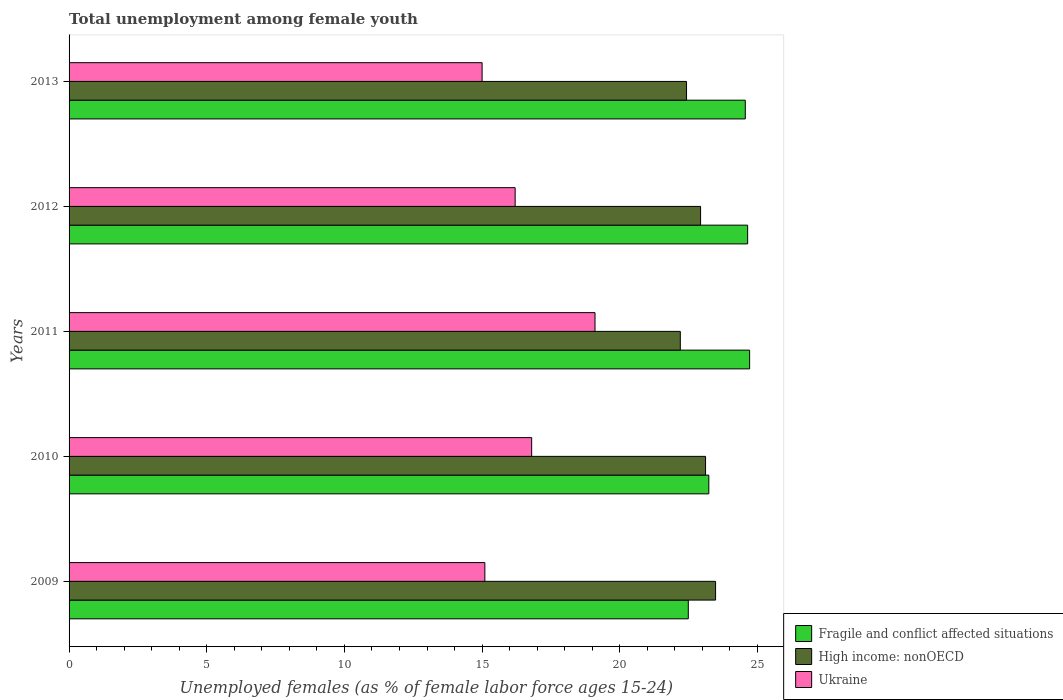How many different coloured bars are there?
Your answer should be compact. 3. How many groups of bars are there?
Offer a terse response. 5. Are the number of bars on each tick of the Y-axis equal?
Your answer should be compact. Yes. How many bars are there on the 2nd tick from the top?
Make the answer very short. 3. Across all years, what is the maximum percentage of unemployed females in in Fragile and conflict affected situations?
Keep it short and to the point. 24.71. Across all years, what is the minimum percentage of unemployed females in in Fragile and conflict affected situations?
Give a very brief answer. 22.49. What is the total percentage of unemployed females in in Fragile and conflict affected situations in the graph?
Offer a terse response. 119.64. What is the difference between the percentage of unemployed females in in Fragile and conflict affected situations in 2012 and that in 2013?
Your answer should be compact. 0.08. What is the difference between the percentage of unemployed females in in Fragile and conflict affected situations in 2010 and the percentage of unemployed females in in High income: nonOECD in 2013?
Provide a succinct answer. 0.81. What is the average percentage of unemployed females in in Ukraine per year?
Provide a short and direct response. 16.44. In the year 2013, what is the difference between the percentage of unemployed females in in Fragile and conflict affected situations and percentage of unemployed females in in Ukraine?
Give a very brief answer. 9.56. In how many years, is the percentage of unemployed females in in Ukraine greater than 15 %?
Offer a terse response. 4. What is the ratio of the percentage of unemployed females in in High income: nonOECD in 2009 to that in 2013?
Your answer should be compact. 1.05. What is the difference between the highest and the second highest percentage of unemployed females in in High income: nonOECD?
Offer a terse response. 0.36. What is the difference between the highest and the lowest percentage of unemployed females in in High income: nonOECD?
Your answer should be compact. 1.28. In how many years, is the percentage of unemployed females in in Ukraine greater than the average percentage of unemployed females in in Ukraine taken over all years?
Make the answer very short. 2. What does the 2nd bar from the top in 2010 represents?
Give a very brief answer. High income: nonOECD. What does the 1st bar from the bottom in 2011 represents?
Provide a short and direct response. Fragile and conflict affected situations. Are all the bars in the graph horizontal?
Give a very brief answer. Yes. What is the difference between two consecutive major ticks on the X-axis?
Provide a succinct answer. 5. Does the graph contain any zero values?
Offer a terse response. No. Where does the legend appear in the graph?
Make the answer very short. Bottom right. How are the legend labels stacked?
Ensure brevity in your answer.  Vertical. What is the title of the graph?
Ensure brevity in your answer.  Total unemployment among female youth. Does "Cameroon" appear as one of the legend labels in the graph?
Make the answer very short. No. What is the label or title of the X-axis?
Give a very brief answer. Unemployed females (as % of female labor force ages 15-24). What is the label or title of the Y-axis?
Give a very brief answer. Years. What is the Unemployed females (as % of female labor force ages 15-24) in Fragile and conflict affected situations in 2009?
Offer a terse response. 22.49. What is the Unemployed females (as % of female labor force ages 15-24) in High income: nonOECD in 2009?
Give a very brief answer. 23.48. What is the Unemployed females (as % of female labor force ages 15-24) in Ukraine in 2009?
Provide a succinct answer. 15.1. What is the Unemployed females (as % of female labor force ages 15-24) of Fragile and conflict affected situations in 2010?
Your answer should be very brief. 23.23. What is the Unemployed females (as % of female labor force ages 15-24) of High income: nonOECD in 2010?
Ensure brevity in your answer.  23.11. What is the Unemployed females (as % of female labor force ages 15-24) in Ukraine in 2010?
Your answer should be compact. 16.8. What is the Unemployed females (as % of female labor force ages 15-24) of Fragile and conflict affected situations in 2011?
Offer a very short reply. 24.71. What is the Unemployed females (as % of female labor force ages 15-24) in High income: nonOECD in 2011?
Your answer should be very brief. 22.2. What is the Unemployed females (as % of female labor force ages 15-24) of Ukraine in 2011?
Provide a short and direct response. 19.1. What is the Unemployed females (as % of female labor force ages 15-24) of Fragile and conflict affected situations in 2012?
Your answer should be compact. 24.64. What is the Unemployed females (as % of female labor force ages 15-24) in High income: nonOECD in 2012?
Make the answer very short. 22.93. What is the Unemployed females (as % of female labor force ages 15-24) of Ukraine in 2012?
Your answer should be very brief. 16.2. What is the Unemployed females (as % of female labor force ages 15-24) in Fragile and conflict affected situations in 2013?
Ensure brevity in your answer.  24.56. What is the Unemployed females (as % of female labor force ages 15-24) in High income: nonOECD in 2013?
Your response must be concise. 22.42. What is the Unemployed females (as % of female labor force ages 15-24) in Ukraine in 2013?
Offer a terse response. 15. Across all years, what is the maximum Unemployed females (as % of female labor force ages 15-24) in Fragile and conflict affected situations?
Keep it short and to the point. 24.71. Across all years, what is the maximum Unemployed females (as % of female labor force ages 15-24) in High income: nonOECD?
Provide a succinct answer. 23.48. Across all years, what is the maximum Unemployed females (as % of female labor force ages 15-24) in Ukraine?
Give a very brief answer. 19.1. Across all years, what is the minimum Unemployed females (as % of female labor force ages 15-24) of Fragile and conflict affected situations?
Your response must be concise. 22.49. Across all years, what is the minimum Unemployed females (as % of female labor force ages 15-24) of High income: nonOECD?
Provide a short and direct response. 22.2. Across all years, what is the minimum Unemployed females (as % of female labor force ages 15-24) in Ukraine?
Your answer should be very brief. 15. What is the total Unemployed females (as % of female labor force ages 15-24) of Fragile and conflict affected situations in the graph?
Your answer should be very brief. 119.64. What is the total Unemployed females (as % of female labor force ages 15-24) of High income: nonOECD in the graph?
Make the answer very short. 114.15. What is the total Unemployed females (as % of female labor force ages 15-24) in Ukraine in the graph?
Your answer should be very brief. 82.2. What is the difference between the Unemployed females (as % of female labor force ages 15-24) of Fragile and conflict affected situations in 2009 and that in 2010?
Your response must be concise. -0.75. What is the difference between the Unemployed females (as % of female labor force ages 15-24) of High income: nonOECD in 2009 and that in 2010?
Make the answer very short. 0.36. What is the difference between the Unemployed females (as % of female labor force ages 15-24) in Ukraine in 2009 and that in 2010?
Keep it short and to the point. -1.7. What is the difference between the Unemployed females (as % of female labor force ages 15-24) of Fragile and conflict affected situations in 2009 and that in 2011?
Keep it short and to the point. -2.23. What is the difference between the Unemployed females (as % of female labor force ages 15-24) in High income: nonOECD in 2009 and that in 2011?
Keep it short and to the point. 1.28. What is the difference between the Unemployed females (as % of female labor force ages 15-24) in Ukraine in 2009 and that in 2011?
Your answer should be very brief. -4. What is the difference between the Unemployed females (as % of female labor force ages 15-24) of Fragile and conflict affected situations in 2009 and that in 2012?
Your response must be concise. -2.16. What is the difference between the Unemployed females (as % of female labor force ages 15-24) of High income: nonOECD in 2009 and that in 2012?
Your answer should be very brief. 0.54. What is the difference between the Unemployed females (as % of female labor force ages 15-24) in Ukraine in 2009 and that in 2012?
Your answer should be compact. -1.1. What is the difference between the Unemployed females (as % of female labor force ages 15-24) in Fragile and conflict affected situations in 2009 and that in 2013?
Keep it short and to the point. -2.07. What is the difference between the Unemployed females (as % of female labor force ages 15-24) in High income: nonOECD in 2009 and that in 2013?
Your answer should be very brief. 1.06. What is the difference between the Unemployed females (as % of female labor force ages 15-24) in Fragile and conflict affected situations in 2010 and that in 2011?
Give a very brief answer. -1.48. What is the difference between the Unemployed females (as % of female labor force ages 15-24) in Fragile and conflict affected situations in 2010 and that in 2012?
Your answer should be very brief. -1.41. What is the difference between the Unemployed females (as % of female labor force ages 15-24) of High income: nonOECD in 2010 and that in 2012?
Ensure brevity in your answer.  0.18. What is the difference between the Unemployed females (as % of female labor force ages 15-24) in Ukraine in 2010 and that in 2012?
Provide a short and direct response. 0.6. What is the difference between the Unemployed females (as % of female labor force ages 15-24) of Fragile and conflict affected situations in 2010 and that in 2013?
Offer a terse response. -1.32. What is the difference between the Unemployed females (as % of female labor force ages 15-24) of High income: nonOECD in 2010 and that in 2013?
Your answer should be compact. 0.69. What is the difference between the Unemployed females (as % of female labor force ages 15-24) in Ukraine in 2010 and that in 2013?
Your response must be concise. 1.8. What is the difference between the Unemployed females (as % of female labor force ages 15-24) in Fragile and conflict affected situations in 2011 and that in 2012?
Offer a terse response. 0.07. What is the difference between the Unemployed females (as % of female labor force ages 15-24) of High income: nonOECD in 2011 and that in 2012?
Provide a succinct answer. -0.74. What is the difference between the Unemployed females (as % of female labor force ages 15-24) in Ukraine in 2011 and that in 2012?
Offer a very short reply. 2.9. What is the difference between the Unemployed females (as % of female labor force ages 15-24) of Fragile and conflict affected situations in 2011 and that in 2013?
Offer a terse response. 0.16. What is the difference between the Unemployed females (as % of female labor force ages 15-24) in High income: nonOECD in 2011 and that in 2013?
Make the answer very short. -0.23. What is the difference between the Unemployed females (as % of female labor force ages 15-24) of Fragile and conflict affected situations in 2012 and that in 2013?
Your answer should be compact. 0.09. What is the difference between the Unemployed females (as % of female labor force ages 15-24) of High income: nonOECD in 2012 and that in 2013?
Ensure brevity in your answer.  0.51. What is the difference between the Unemployed females (as % of female labor force ages 15-24) of Ukraine in 2012 and that in 2013?
Keep it short and to the point. 1.2. What is the difference between the Unemployed females (as % of female labor force ages 15-24) in Fragile and conflict affected situations in 2009 and the Unemployed females (as % of female labor force ages 15-24) in High income: nonOECD in 2010?
Ensure brevity in your answer.  -0.63. What is the difference between the Unemployed females (as % of female labor force ages 15-24) in Fragile and conflict affected situations in 2009 and the Unemployed females (as % of female labor force ages 15-24) in Ukraine in 2010?
Provide a succinct answer. 5.69. What is the difference between the Unemployed females (as % of female labor force ages 15-24) in High income: nonOECD in 2009 and the Unemployed females (as % of female labor force ages 15-24) in Ukraine in 2010?
Offer a very short reply. 6.68. What is the difference between the Unemployed females (as % of female labor force ages 15-24) in Fragile and conflict affected situations in 2009 and the Unemployed females (as % of female labor force ages 15-24) in High income: nonOECD in 2011?
Ensure brevity in your answer.  0.29. What is the difference between the Unemployed females (as % of female labor force ages 15-24) in Fragile and conflict affected situations in 2009 and the Unemployed females (as % of female labor force ages 15-24) in Ukraine in 2011?
Your response must be concise. 3.39. What is the difference between the Unemployed females (as % of female labor force ages 15-24) of High income: nonOECD in 2009 and the Unemployed females (as % of female labor force ages 15-24) of Ukraine in 2011?
Offer a very short reply. 4.38. What is the difference between the Unemployed females (as % of female labor force ages 15-24) of Fragile and conflict affected situations in 2009 and the Unemployed females (as % of female labor force ages 15-24) of High income: nonOECD in 2012?
Give a very brief answer. -0.45. What is the difference between the Unemployed females (as % of female labor force ages 15-24) in Fragile and conflict affected situations in 2009 and the Unemployed females (as % of female labor force ages 15-24) in Ukraine in 2012?
Ensure brevity in your answer.  6.29. What is the difference between the Unemployed females (as % of female labor force ages 15-24) of High income: nonOECD in 2009 and the Unemployed females (as % of female labor force ages 15-24) of Ukraine in 2012?
Provide a succinct answer. 7.28. What is the difference between the Unemployed females (as % of female labor force ages 15-24) of Fragile and conflict affected situations in 2009 and the Unemployed females (as % of female labor force ages 15-24) of High income: nonOECD in 2013?
Your answer should be compact. 0.06. What is the difference between the Unemployed females (as % of female labor force ages 15-24) of Fragile and conflict affected situations in 2009 and the Unemployed females (as % of female labor force ages 15-24) of Ukraine in 2013?
Your answer should be compact. 7.49. What is the difference between the Unemployed females (as % of female labor force ages 15-24) in High income: nonOECD in 2009 and the Unemployed females (as % of female labor force ages 15-24) in Ukraine in 2013?
Keep it short and to the point. 8.48. What is the difference between the Unemployed females (as % of female labor force ages 15-24) of Fragile and conflict affected situations in 2010 and the Unemployed females (as % of female labor force ages 15-24) of High income: nonOECD in 2011?
Your answer should be compact. 1.04. What is the difference between the Unemployed females (as % of female labor force ages 15-24) of Fragile and conflict affected situations in 2010 and the Unemployed females (as % of female labor force ages 15-24) of Ukraine in 2011?
Keep it short and to the point. 4.13. What is the difference between the Unemployed females (as % of female labor force ages 15-24) of High income: nonOECD in 2010 and the Unemployed females (as % of female labor force ages 15-24) of Ukraine in 2011?
Keep it short and to the point. 4.01. What is the difference between the Unemployed females (as % of female labor force ages 15-24) of Fragile and conflict affected situations in 2010 and the Unemployed females (as % of female labor force ages 15-24) of High income: nonOECD in 2012?
Your answer should be very brief. 0.3. What is the difference between the Unemployed females (as % of female labor force ages 15-24) in Fragile and conflict affected situations in 2010 and the Unemployed females (as % of female labor force ages 15-24) in Ukraine in 2012?
Your response must be concise. 7.03. What is the difference between the Unemployed females (as % of female labor force ages 15-24) of High income: nonOECD in 2010 and the Unemployed females (as % of female labor force ages 15-24) of Ukraine in 2012?
Keep it short and to the point. 6.91. What is the difference between the Unemployed females (as % of female labor force ages 15-24) of Fragile and conflict affected situations in 2010 and the Unemployed females (as % of female labor force ages 15-24) of High income: nonOECD in 2013?
Provide a succinct answer. 0.81. What is the difference between the Unemployed females (as % of female labor force ages 15-24) in Fragile and conflict affected situations in 2010 and the Unemployed females (as % of female labor force ages 15-24) in Ukraine in 2013?
Offer a very short reply. 8.23. What is the difference between the Unemployed females (as % of female labor force ages 15-24) of High income: nonOECD in 2010 and the Unemployed females (as % of female labor force ages 15-24) of Ukraine in 2013?
Make the answer very short. 8.11. What is the difference between the Unemployed females (as % of female labor force ages 15-24) of Fragile and conflict affected situations in 2011 and the Unemployed females (as % of female labor force ages 15-24) of High income: nonOECD in 2012?
Provide a succinct answer. 1.78. What is the difference between the Unemployed females (as % of female labor force ages 15-24) of Fragile and conflict affected situations in 2011 and the Unemployed females (as % of female labor force ages 15-24) of Ukraine in 2012?
Your response must be concise. 8.51. What is the difference between the Unemployed females (as % of female labor force ages 15-24) of High income: nonOECD in 2011 and the Unemployed females (as % of female labor force ages 15-24) of Ukraine in 2012?
Your response must be concise. 6. What is the difference between the Unemployed females (as % of female labor force ages 15-24) of Fragile and conflict affected situations in 2011 and the Unemployed females (as % of female labor force ages 15-24) of High income: nonOECD in 2013?
Give a very brief answer. 2.29. What is the difference between the Unemployed females (as % of female labor force ages 15-24) of Fragile and conflict affected situations in 2011 and the Unemployed females (as % of female labor force ages 15-24) of Ukraine in 2013?
Provide a short and direct response. 9.71. What is the difference between the Unemployed females (as % of female labor force ages 15-24) in High income: nonOECD in 2011 and the Unemployed females (as % of female labor force ages 15-24) in Ukraine in 2013?
Make the answer very short. 7.2. What is the difference between the Unemployed females (as % of female labor force ages 15-24) in Fragile and conflict affected situations in 2012 and the Unemployed females (as % of female labor force ages 15-24) in High income: nonOECD in 2013?
Offer a very short reply. 2.22. What is the difference between the Unemployed females (as % of female labor force ages 15-24) of Fragile and conflict affected situations in 2012 and the Unemployed females (as % of female labor force ages 15-24) of Ukraine in 2013?
Offer a very short reply. 9.64. What is the difference between the Unemployed females (as % of female labor force ages 15-24) in High income: nonOECD in 2012 and the Unemployed females (as % of female labor force ages 15-24) in Ukraine in 2013?
Provide a succinct answer. 7.93. What is the average Unemployed females (as % of female labor force ages 15-24) of Fragile and conflict affected situations per year?
Give a very brief answer. 23.93. What is the average Unemployed females (as % of female labor force ages 15-24) in High income: nonOECD per year?
Make the answer very short. 22.83. What is the average Unemployed females (as % of female labor force ages 15-24) in Ukraine per year?
Provide a short and direct response. 16.44. In the year 2009, what is the difference between the Unemployed females (as % of female labor force ages 15-24) of Fragile and conflict affected situations and Unemployed females (as % of female labor force ages 15-24) of High income: nonOECD?
Your response must be concise. -0.99. In the year 2009, what is the difference between the Unemployed females (as % of female labor force ages 15-24) of Fragile and conflict affected situations and Unemployed females (as % of female labor force ages 15-24) of Ukraine?
Give a very brief answer. 7.39. In the year 2009, what is the difference between the Unemployed females (as % of female labor force ages 15-24) of High income: nonOECD and Unemployed females (as % of female labor force ages 15-24) of Ukraine?
Provide a short and direct response. 8.38. In the year 2010, what is the difference between the Unemployed females (as % of female labor force ages 15-24) of Fragile and conflict affected situations and Unemployed females (as % of female labor force ages 15-24) of High income: nonOECD?
Your answer should be compact. 0.12. In the year 2010, what is the difference between the Unemployed females (as % of female labor force ages 15-24) in Fragile and conflict affected situations and Unemployed females (as % of female labor force ages 15-24) in Ukraine?
Your answer should be compact. 6.43. In the year 2010, what is the difference between the Unemployed females (as % of female labor force ages 15-24) in High income: nonOECD and Unemployed females (as % of female labor force ages 15-24) in Ukraine?
Provide a succinct answer. 6.31. In the year 2011, what is the difference between the Unemployed females (as % of female labor force ages 15-24) of Fragile and conflict affected situations and Unemployed females (as % of female labor force ages 15-24) of High income: nonOECD?
Your answer should be very brief. 2.52. In the year 2011, what is the difference between the Unemployed females (as % of female labor force ages 15-24) of Fragile and conflict affected situations and Unemployed females (as % of female labor force ages 15-24) of Ukraine?
Make the answer very short. 5.61. In the year 2011, what is the difference between the Unemployed females (as % of female labor force ages 15-24) of High income: nonOECD and Unemployed females (as % of female labor force ages 15-24) of Ukraine?
Provide a succinct answer. 3.1. In the year 2012, what is the difference between the Unemployed females (as % of female labor force ages 15-24) in Fragile and conflict affected situations and Unemployed females (as % of female labor force ages 15-24) in High income: nonOECD?
Ensure brevity in your answer.  1.71. In the year 2012, what is the difference between the Unemployed females (as % of female labor force ages 15-24) of Fragile and conflict affected situations and Unemployed females (as % of female labor force ages 15-24) of Ukraine?
Your answer should be very brief. 8.44. In the year 2012, what is the difference between the Unemployed females (as % of female labor force ages 15-24) of High income: nonOECD and Unemployed females (as % of female labor force ages 15-24) of Ukraine?
Offer a terse response. 6.73. In the year 2013, what is the difference between the Unemployed females (as % of female labor force ages 15-24) of Fragile and conflict affected situations and Unemployed females (as % of female labor force ages 15-24) of High income: nonOECD?
Your answer should be compact. 2.13. In the year 2013, what is the difference between the Unemployed females (as % of female labor force ages 15-24) of Fragile and conflict affected situations and Unemployed females (as % of female labor force ages 15-24) of Ukraine?
Ensure brevity in your answer.  9.56. In the year 2013, what is the difference between the Unemployed females (as % of female labor force ages 15-24) in High income: nonOECD and Unemployed females (as % of female labor force ages 15-24) in Ukraine?
Keep it short and to the point. 7.42. What is the ratio of the Unemployed females (as % of female labor force ages 15-24) of Fragile and conflict affected situations in 2009 to that in 2010?
Your response must be concise. 0.97. What is the ratio of the Unemployed females (as % of female labor force ages 15-24) in High income: nonOECD in 2009 to that in 2010?
Keep it short and to the point. 1.02. What is the ratio of the Unemployed females (as % of female labor force ages 15-24) of Ukraine in 2009 to that in 2010?
Provide a short and direct response. 0.9. What is the ratio of the Unemployed females (as % of female labor force ages 15-24) of Fragile and conflict affected situations in 2009 to that in 2011?
Offer a terse response. 0.91. What is the ratio of the Unemployed females (as % of female labor force ages 15-24) of High income: nonOECD in 2009 to that in 2011?
Ensure brevity in your answer.  1.06. What is the ratio of the Unemployed females (as % of female labor force ages 15-24) in Ukraine in 2009 to that in 2011?
Offer a very short reply. 0.79. What is the ratio of the Unemployed females (as % of female labor force ages 15-24) in Fragile and conflict affected situations in 2009 to that in 2012?
Give a very brief answer. 0.91. What is the ratio of the Unemployed females (as % of female labor force ages 15-24) of High income: nonOECD in 2009 to that in 2012?
Your response must be concise. 1.02. What is the ratio of the Unemployed females (as % of female labor force ages 15-24) in Ukraine in 2009 to that in 2012?
Give a very brief answer. 0.93. What is the ratio of the Unemployed females (as % of female labor force ages 15-24) of Fragile and conflict affected situations in 2009 to that in 2013?
Give a very brief answer. 0.92. What is the ratio of the Unemployed females (as % of female labor force ages 15-24) in High income: nonOECD in 2009 to that in 2013?
Your answer should be compact. 1.05. What is the ratio of the Unemployed females (as % of female labor force ages 15-24) of High income: nonOECD in 2010 to that in 2011?
Ensure brevity in your answer.  1.04. What is the ratio of the Unemployed females (as % of female labor force ages 15-24) in Ukraine in 2010 to that in 2011?
Ensure brevity in your answer.  0.88. What is the ratio of the Unemployed females (as % of female labor force ages 15-24) of Fragile and conflict affected situations in 2010 to that in 2012?
Keep it short and to the point. 0.94. What is the ratio of the Unemployed females (as % of female labor force ages 15-24) of High income: nonOECD in 2010 to that in 2012?
Offer a terse response. 1.01. What is the ratio of the Unemployed females (as % of female labor force ages 15-24) of Ukraine in 2010 to that in 2012?
Offer a very short reply. 1.04. What is the ratio of the Unemployed females (as % of female labor force ages 15-24) of Fragile and conflict affected situations in 2010 to that in 2013?
Your answer should be very brief. 0.95. What is the ratio of the Unemployed females (as % of female labor force ages 15-24) in High income: nonOECD in 2010 to that in 2013?
Make the answer very short. 1.03. What is the ratio of the Unemployed females (as % of female labor force ages 15-24) in Ukraine in 2010 to that in 2013?
Give a very brief answer. 1.12. What is the ratio of the Unemployed females (as % of female labor force ages 15-24) of High income: nonOECD in 2011 to that in 2012?
Your response must be concise. 0.97. What is the ratio of the Unemployed females (as % of female labor force ages 15-24) of Ukraine in 2011 to that in 2012?
Your answer should be very brief. 1.18. What is the ratio of the Unemployed females (as % of female labor force ages 15-24) in Fragile and conflict affected situations in 2011 to that in 2013?
Offer a terse response. 1.01. What is the ratio of the Unemployed females (as % of female labor force ages 15-24) in Ukraine in 2011 to that in 2013?
Offer a very short reply. 1.27. What is the ratio of the Unemployed females (as % of female labor force ages 15-24) in High income: nonOECD in 2012 to that in 2013?
Provide a short and direct response. 1.02. What is the difference between the highest and the second highest Unemployed females (as % of female labor force ages 15-24) in Fragile and conflict affected situations?
Your answer should be compact. 0.07. What is the difference between the highest and the second highest Unemployed females (as % of female labor force ages 15-24) of High income: nonOECD?
Provide a short and direct response. 0.36. What is the difference between the highest and the second highest Unemployed females (as % of female labor force ages 15-24) in Ukraine?
Ensure brevity in your answer.  2.3. What is the difference between the highest and the lowest Unemployed females (as % of female labor force ages 15-24) in Fragile and conflict affected situations?
Provide a short and direct response. 2.23. What is the difference between the highest and the lowest Unemployed females (as % of female labor force ages 15-24) in High income: nonOECD?
Provide a succinct answer. 1.28. What is the difference between the highest and the lowest Unemployed females (as % of female labor force ages 15-24) in Ukraine?
Give a very brief answer. 4.1. 